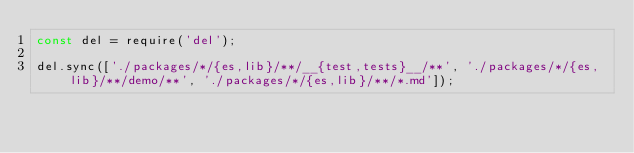<code> <loc_0><loc_0><loc_500><loc_500><_JavaScript_>const del = require('del');

del.sync(['./packages/*/{es,lib}/**/__{test,tests}__/**', './packages/*/{es,lib}/**/demo/**', './packages/*/{es,lib}/**/*.md']);
</code> 